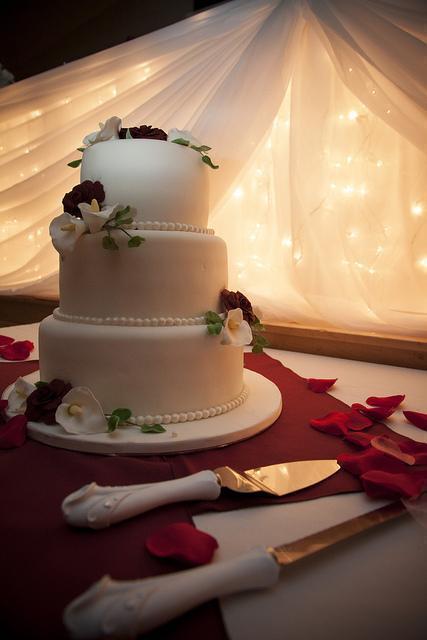Which kind of relationship is this cake typically designed for?
Choose the right answer from the provided options to respond to the question.
Options: Friendship, acquaintanceship, familial, romantic. Romantic. 